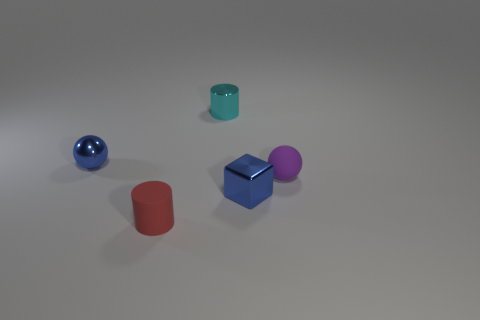What is the material of the ball that is on the right side of the shiny cylinder?
Give a very brief answer. Rubber. Do the small rubber thing that is on the left side of the purple object and the shiny block have the same color?
Keep it short and to the point. No. How big is the shiny object that is in front of the tiny blue thing behind the rubber sphere?
Ensure brevity in your answer.  Small. Are there more red matte objects behind the purple object than small purple things?
Provide a short and direct response. No. Is the size of the blue thing that is in front of the blue metal sphere the same as the tiny red cylinder?
Your response must be concise. Yes. There is a small object that is both in front of the tiny purple object and to the right of the tiny red thing; what color is it?
Give a very brief answer. Blue. What shape is the cyan metal thing that is the same size as the matte cylinder?
Provide a short and direct response. Cylinder. Are there any big matte things that have the same color as the metal cube?
Ensure brevity in your answer.  No. Are there an equal number of small cyan metal cylinders that are in front of the blue sphere and blue metal blocks?
Your answer should be very brief. No. Do the tiny shiny cylinder and the tiny metal cube have the same color?
Offer a terse response. No. 